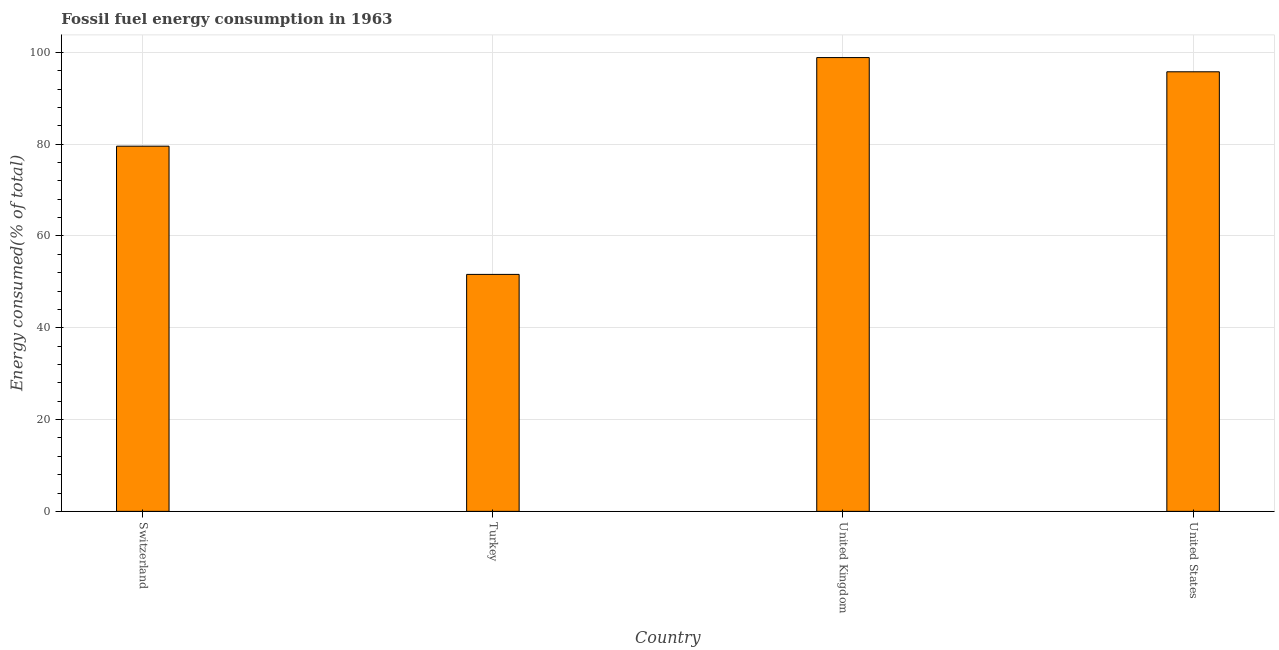Does the graph contain any zero values?
Offer a terse response. No. Does the graph contain grids?
Your answer should be very brief. Yes. What is the title of the graph?
Give a very brief answer. Fossil fuel energy consumption in 1963. What is the label or title of the X-axis?
Make the answer very short. Country. What is the label or title of the Y-axis?
Your response must be concise. Energy consumed(% of total). What is the fossil fuel energy consumption in Turkey?
Your answer should be compact. 51.63. Across all countries, what is the maximum fossil fuel energy consumption?
Keep it short and to the point. 98.87. Across all countries, what is the minimum fossil fuel energy consumption?
Offer a terse response. 51.63. What is the sum of the fossil fuel energy consumption?
Provide a short and direct response. 325.83. What is the difference between the fossil fuel energy consumption in Switzerland and United Kingdom?
Give a very brief answer. -19.3. What is the average fossil fuel energy consumption per country?
Make the answer very short. 81.46. What is the median fossil fuel energy consumption?
Give a very brief answer. 87.67. What is the ratio of the fossil fuel energy consumption in Turkey to that in United Kingdom?
Your answer should be compact. 0.52. Is the fossil fuel energy consumption in Switzerland less than that in United States?
Make the answer very short. Yes. Is the difference between the fossil fuel energy consumption in United Kingdom and United States greater than the difference between any two countries?
Keep it short and to the point. No. What is the difference between the highest and the second highest fossil fuel energy consumption?
Your answer should be very brief. 3.1. Is the sum of the fossil fuel energy consumption in United Kingdom and United States greater than the maximum fossil fuel energy consumption across all countries?
Offer a terse response. Yes. What is the difference between the highest and the lowest fossil fuel energy consumption?
Provide a succinct answer. 47.24. Are all the bars in the graph horizontal?
Your answer should be compact. No. How many countries are there in the graph?
Your response must be concise. 4. What is the difference between two consecutive major ticks on the Y-axis?
Ensure brevity in your answer.  20. What is the Energy consumed(% of total) of Switzerland?
Provide a short and direct response. 79.56. What is the Energy consumed(% of total) in Turkey?
Make the answer very short. 51.63. What is the Energy consumed(% of total) of United Kingdom?
Make the answer very short. 98.87. What is the Energy consumed(% of total) of United States?
Give a very brief answer. 95.77. What is the difference between the Energy consumed(% of total) in Switzerland and Turkey?
Give a very brief answer. 27.94. What is the difference between the Energy consumed(% of total) in Switzerland and United Kingdom?
Provide a short and direct response. -19.31. What is the difference between the Energy consumed(% of total) in Switzerland and United States?
Give a very brief answer. -16.21. What is the difference between the Energy consumed(% of total) in Turkey and United Kingdom?
Your answer should be very brief. -47.24. What is the difference between the Energy consumed(% of total) in Turkey and United States?
Offer a terse response. -44.14. What is the difference between the Energy consumed(% of total) in United Kingdom and United States?
Your response must be concise. 3.1. What is the ratio of the Energy consumed(% of total) in Switzerland to that in Turkey?
Your answer should be compact. 1.54. What is the ratio of the Energy consumed(% of total) in Switzerland to that in United Kingdom?
Provide a succinct answer. 0.81. What is the ratio of the Energy consumed(% of total) in Switzerland to that in United States?
Keep it short and to the point. 0.83. What is the ratio of the Energy consumed(% of total) in Turkey to that in United Kingdom?
Your answer should be compact. 0.52. What is the ratio of the Energy consumed(% of total) in Turkey to that in United States?
Provide a succinct answer. 0.54. What is the ratio of the Energy consumed(% of total) in United Kingdom to that in United States?
Keep it short and to the point. 1.03. 